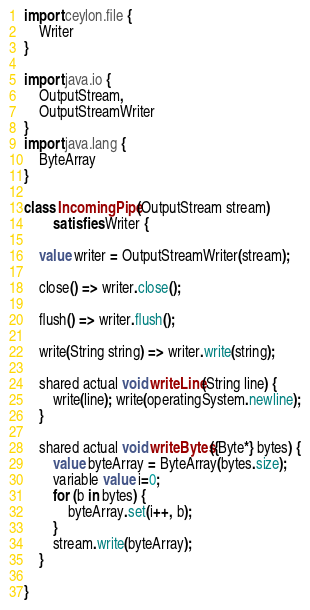Convert code to text. <code><loc_0><loc_0><loc_500><loc_500><_Ceylon_>import ceylon.file {
    Writer
}

import java.io {
    OutputStream,
    OutputStreamWriter
}
import java.lang {
    ByteArray
}

class IncomingPipe(OutputStream stream)
        satisfies Writer {
    
    value writer = OutputStreamWriter(stream);
    
    close() => writer.close();
    
    flush() => writer.flush();
    
    write(String string) => writer.write(string);
    
    shared actual void writeLine(String line) {
        write(line); write(operatingSystem.newline);
    }
    
    shared actual void writeBytes({Byte*} bytes) {
        value byteArray = ByteArray(bytes.size);
        variable value i=0;
        for (b in bytes) {
            byteArray.set(i++, b);
        }
        stream.write(byteArray);
    }
    
}</code> 